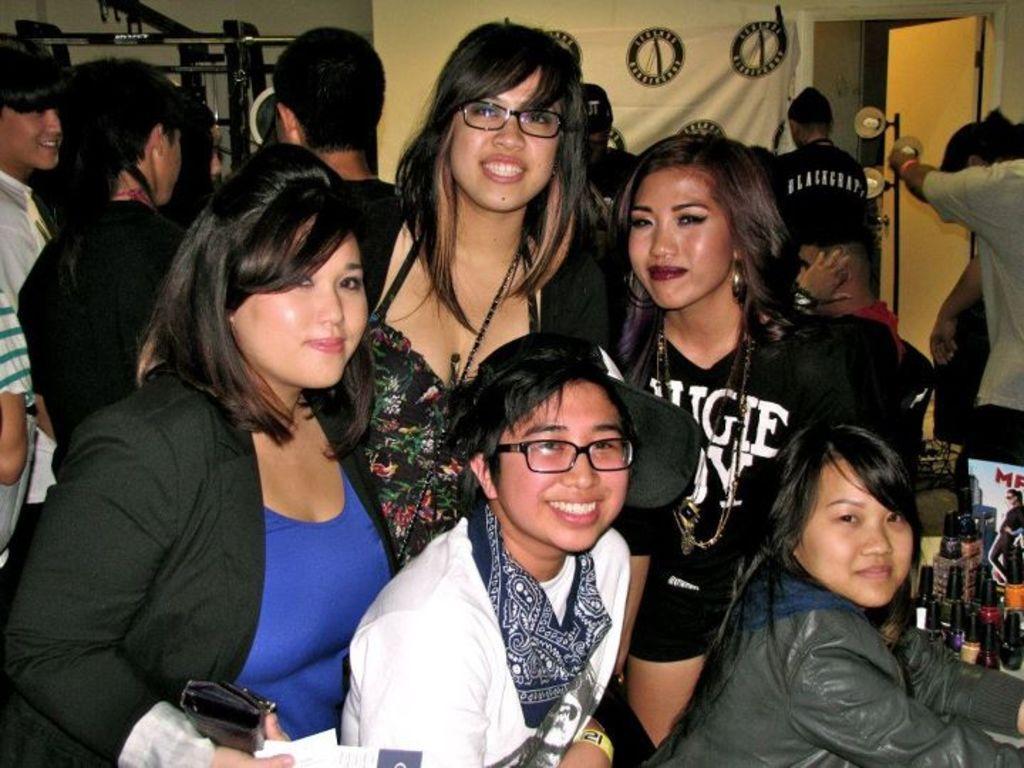Please provide a concise description of this image. In the foreground of the picture I can see a few women and there is a smile on their face. I can see the makeup cosmetics on the bottom right side of the picture. It is looking like a door on the top right side. It is looking like a banner cloth at the top of the picture. 